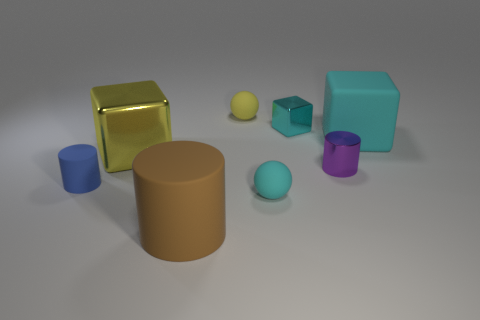Add 1 big purple spheres. How many objects exist? 9 Subtract all balls. How many objects are left? 6 Add 3 rubber objects. How many rubber objects exist? 8 Subtract 0 purple balls. How many objects are left? 8 Subtract all tiny cyan balls. Subtract all small blue things. How many objects are left? 6 Add 5 purple shiny things. How many purple shiny things are left? 6 